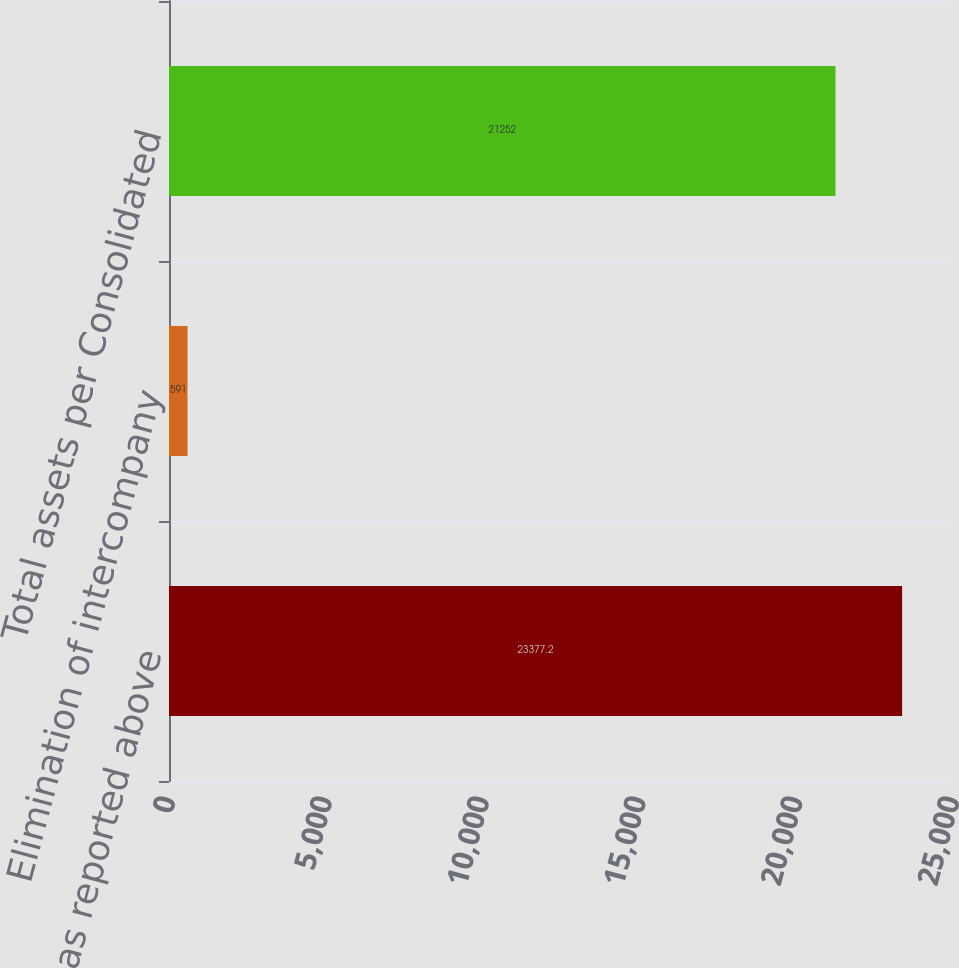Convert chart. <chart><loc_0><loc_0><loc_500><loc_500><bar_chart><fcel>Total assets as reported above<fcel>Elimination of intercompany<fcel>Total assets per Consolidated<nl><fcel>23377.2<fcel>591<fcel>21252<nl></chart> 